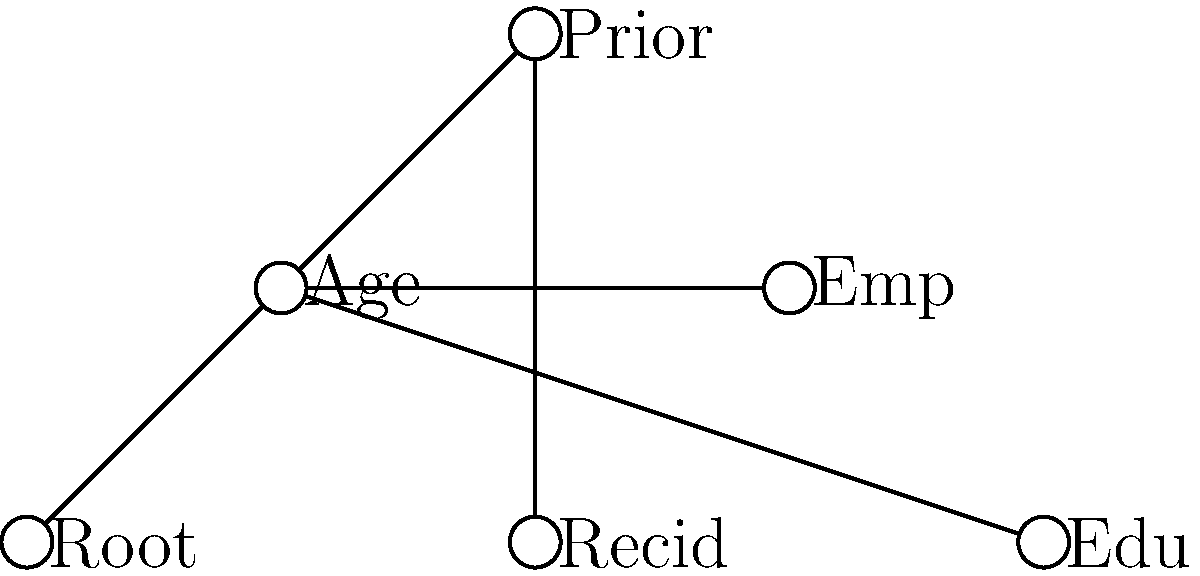In the decision tree shown above for predicting recidivism rates, which factor appears to have the most direct influence on the prediction of recidivism according to the tree structure? To determine which factor has the most direct influence on recidivism prediction, we need to analyze the structure of the decision tree:

1. The root node represents the starting point of the decision-making process.
2. From the root, we see two main branches: "Age" and "Prior" (Prior criminal history).
3. The "Age" branch further splits into "Emp" (Employment) and "Edu" (Education).
4. The "Prior" branch leads directly to "Recid" (Recidivism).

Analyzing the tree structure:
- The "Age" factor leads to two additional factors before potentially reaching a recidivism prediction.
- The "Prior" factor leads directly to the recidivism prediction without any intermediate factors.

Therefore, based on the tree structure, the factor with the most direct influence on the prediction of recidivism is "Prior" (Prior criminal history). This is because it has a direct path to the recidivism prediction node without any intervening factors.

It's important to note that in actual criminological research, the importance of factors would be determined by statistical analysis of data rather than just the structure of a decision tree. However, in this graphical representation, the "Prior" factor appears to have the most direct relationship with recidivism prediction.
Answer: Prior criminal history 